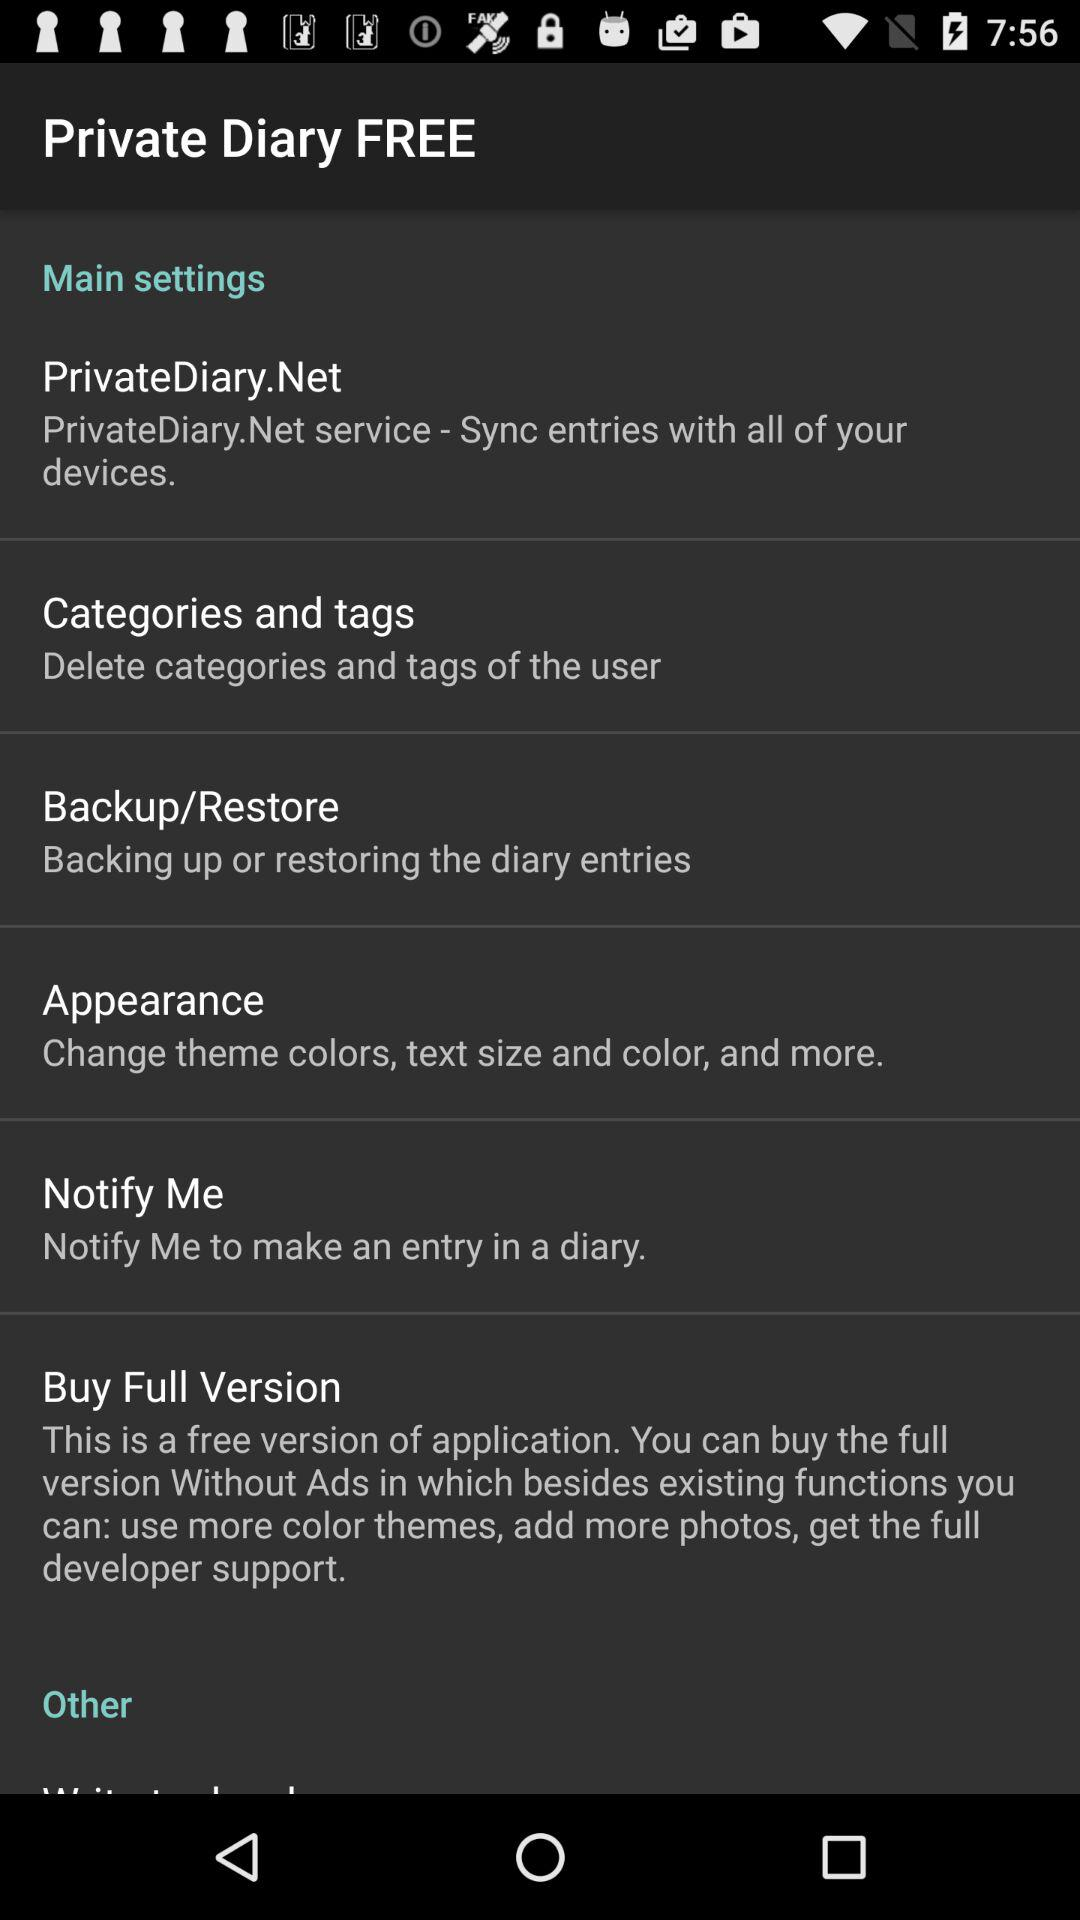How many of the main settings are about syncing?
Answer the question using a single word or phrase. 1 